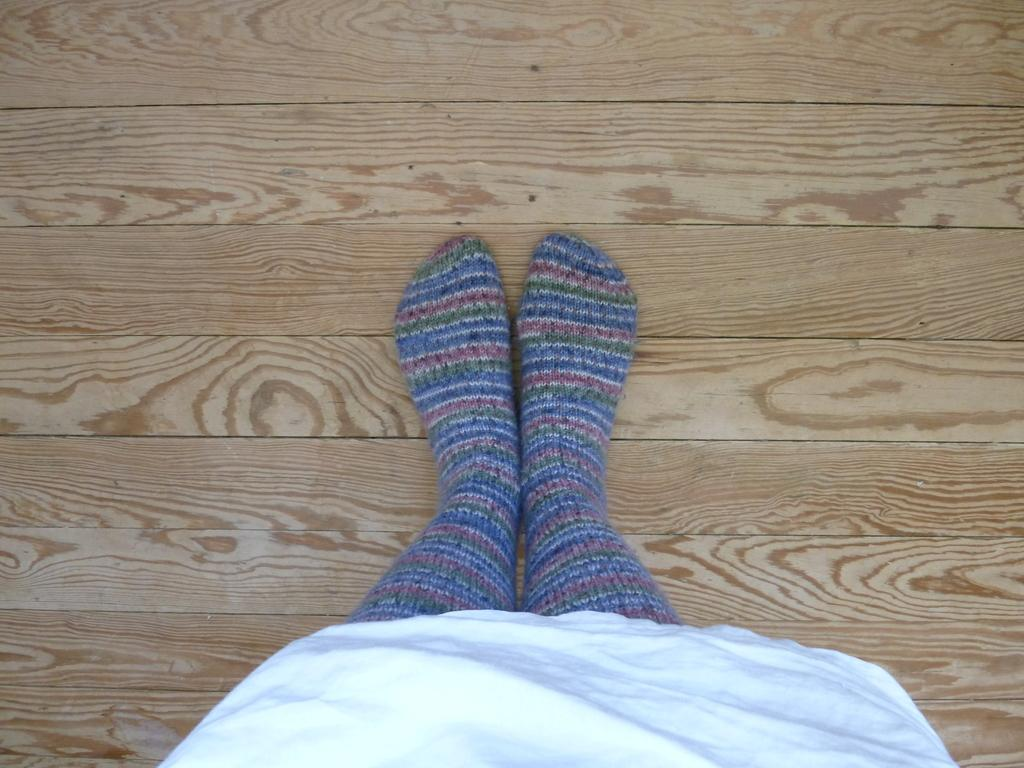Who or what is the main subject in the image? There is a person in the image. What type of clothing is the person wearing on their feet? The person is wearing socks. What is the person's legs resting on in the image? The person has their legs on a wooden platform. How many family members can be seen reading books in the image? There is no mention of family members or books in the image; it only features a person wearing socks and resting their legs on a wooden platform. 